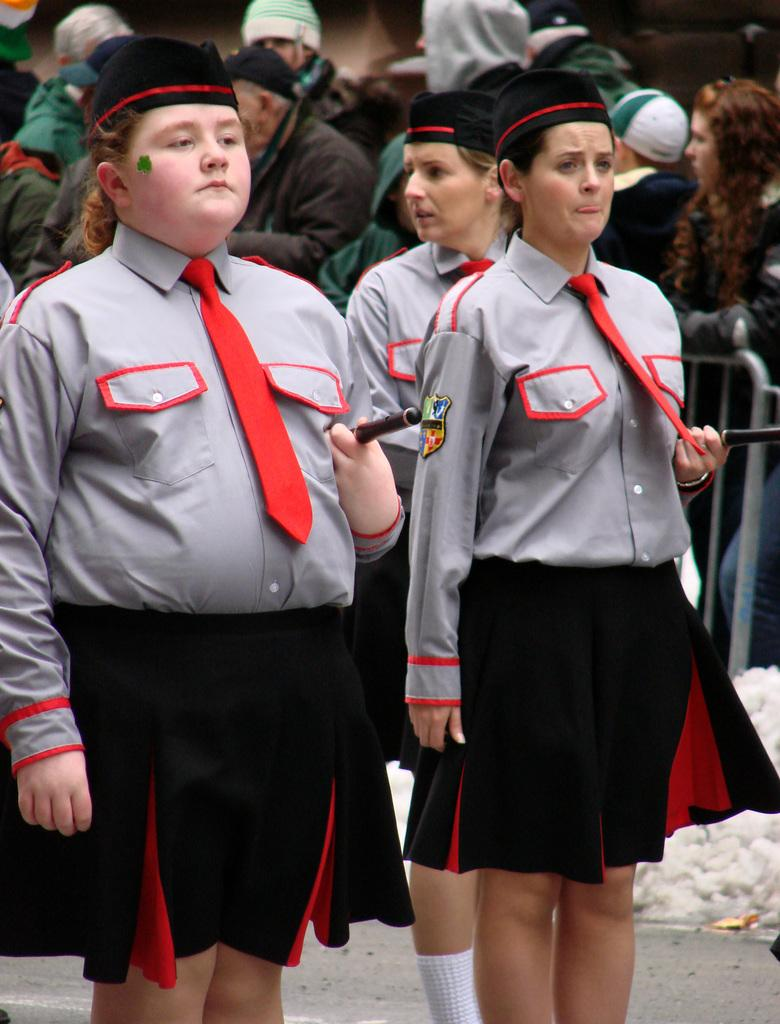How many people are visible in the image? There are three persons standing in the image. Can you describe the background of the image? There is a group of people standing in the background of the image. What is separating the foreground and background in the image? There is a barrier in the image. What type of bulb is being used to power the engine in the image? There is no bulb or engine present in the image. 